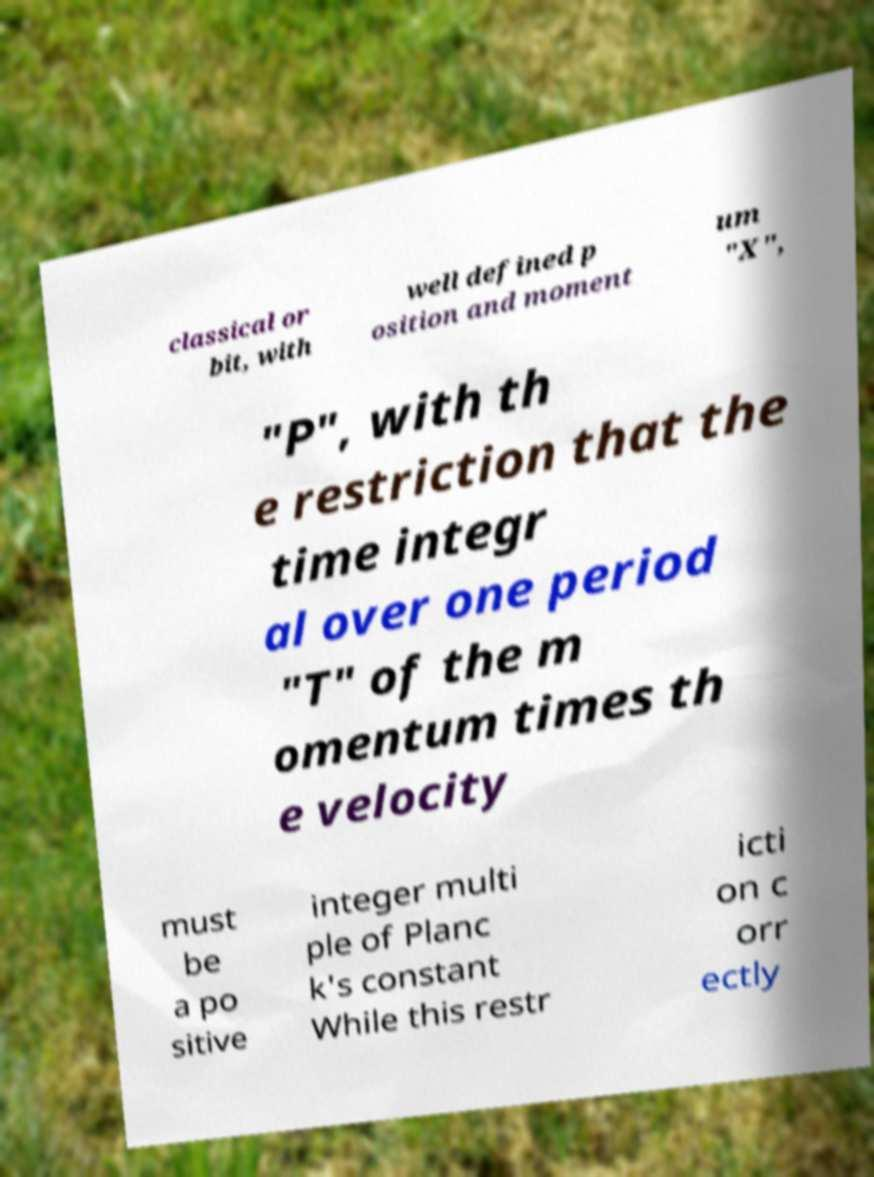Can you accurately transcribe the text from the provided image for me? classical or bit, with well defined p osition and moment um "X", "P", with th e restriction that the time integr al over one period "T" of the m omentum times th e velocity must be a po sitive integer multi ple of Planc k's constant While this restr icti on c orr ectly 